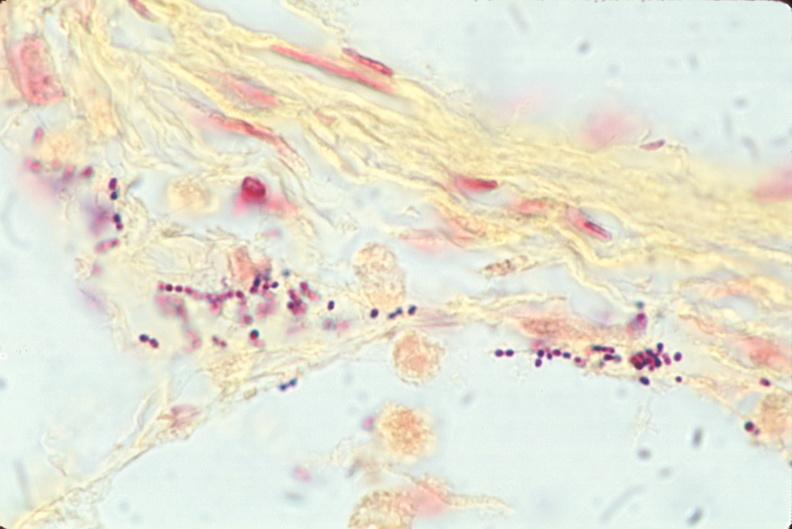where is this?
Answer the question using a single word or phrase. Lung 